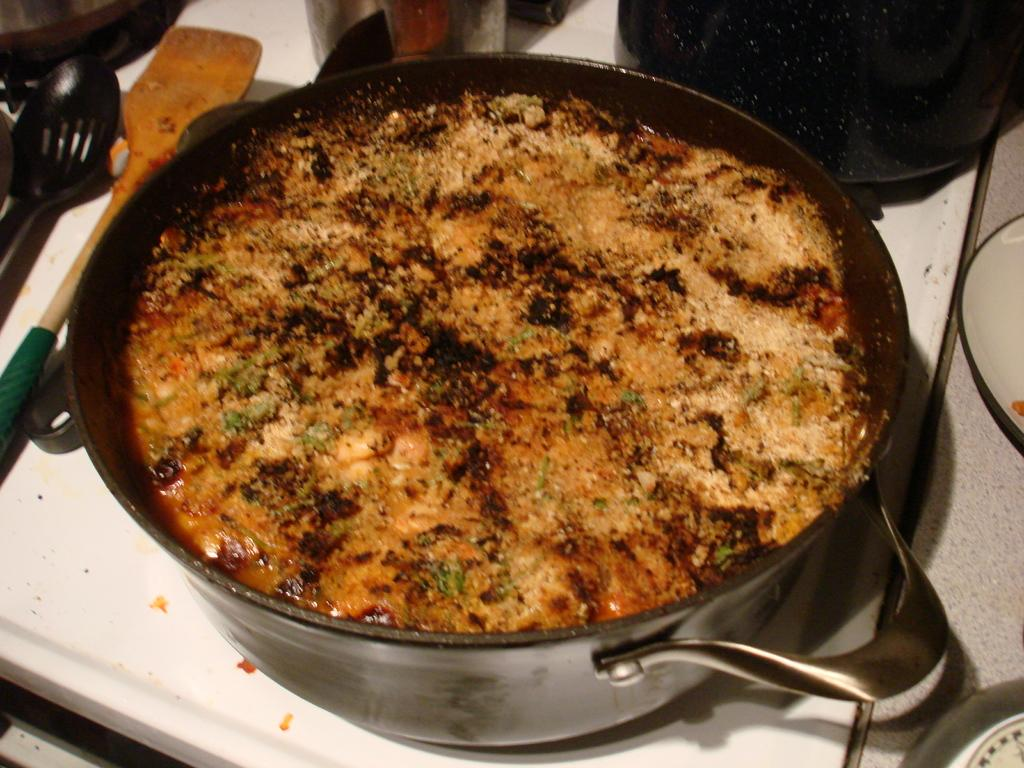What is in the bowl that is visible in the image? There is a bowl containing food in the image. Where is the bowl placed in the image? The bowl is placed on a white table. What utensils can be seen in the image? There are spoons visible in the image. What other items are present on the table in the image? There are vessels and plates in the image. What type of meat is being served in the memory of the image? There is no mention of meat or memory in the image; it only shows a bowl of food, spoons, vessels, and plates on a white table. 